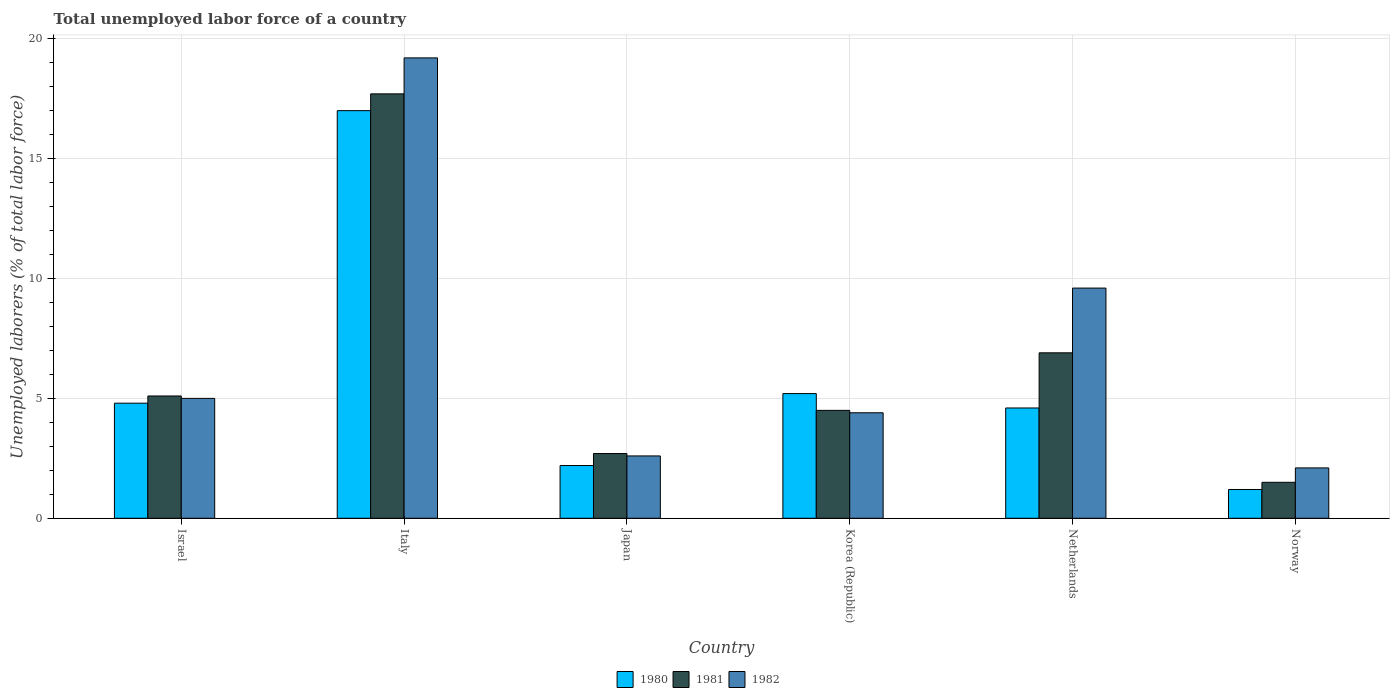How many groups of bars are there?
Offer a very short reply. 6. Are the number of bars per tick equal to the number of legend labels?
Ensure brevity in your answer.  Yes. Are the number of bars on each tick of the X-axis equal?
Your answer should be compact. Yes. How many bars are there on the 1st tick from the right?
Your answer should be very brief. 3. What is the label of the 3rd group of bars from the left?
Offer a terse response. Japan. In how many cases, is the number of bars for a given country not equal to the number of legend labels?
Give a very brief answer. 0. Across all countries, what is the maximum total unemployed labor force in 1982?
Provide a short and direct response. 19.2. Across all countries, what is the minimum total unemployed labor force in 1980?
Give a very brief answer. 1.2. In which country was the total unemployed labor force in 1982 maximum?
Keep it short and to the point. Italy. What is the total total unemployed labor force in 1981 in the graph?
Your response must be concise. 38.4. What is the difference between the total unemployed labor force in 1981 in Israel and that in Italy?
Your response must be concise. -12.6. What is the difference between the total unemployed labor force in 1981 in Norway and the total unemployed labor force in 1982 in Korea (Republic)?
Make the answer very short. -2.9. What is the average total unemployed labor force in 1982 per country?
Provide a succinct answer. 7.15. What is the difference between the total unemployed labor force of/in 1980 and total unemployed labor force of/in 1982 in Netherlands?
Ensure brevity in your answer.  -5. What is the ratio of the total unemployed labor force in 1982 in Japan to that in Netherlands?
Ensure brevity in your answer.  0.27. Is the total unemployed labor force in 1981 in Korea (Republic) less than that in Norway?
Keep it short and to the point. No. Is the difference between the total unemployed labor force in 1980 in Israel and Japan greater than the difference between the total unemployed labor force in 1982 in Israel and Japan?
Ensure brevity in your answer.  Yes. What is the difference between the highest and the second highest total unemployed labor force in 1982?
Offer a terse response. -9.6. What is the difference between the highest and the lowest total unemployed labor force in 1982?
Keep it short and to the point. 17.1. In how many countries, is the total unemployed labor force in 1981 greater than the average total unemployed labor force in 1981 taken over all countries?
Keep it short and to the point. 2. How many bars are there?
Provide a succinct answer. 18. Are all the bars in the graph horizontal?
Ensure brevity in your answer.  No. How many countries are there in the graph?
Your answer should be very brief. 6. Are the values on the major ticks of Y-axis written in scientific E-notation?
Make the answer very short. No. How many legend labels are there?
Provide a short and direct response. 3. What is the title of the graph?
Ensure brevity in your answer.  Total unemployed labor force of a country. Does "2001" appear as one of the legend labels in the graph?
Make the answer very short. No. What is the label or title of the X-axis?
Give a very brief answer. Country. What is the label or title of the Y-axis?
Keep it short and to the point. Unemployed laborers (% of total labor force). What is the Unemployed laborers (% of total labor force) of 1980 in Israel?
Provide a succinct answer. 4.8. What is the Unemployed laborers (% of total labor force) of 1981 in Israel?
Provide a succinct answer. 5.1. What is the Unemployed laborers (% of total labor force) of 1980 in Italy?
Your answer should be very brief. 17. What is the Unemployed laborers (% of total labor force) of 1981 in Italy?
Provide a short and direct response. 17.7. What is the Unemployed laborers (% of total labor force) of 1982 in Italy?
Your answer should be very brief. 19.2. What is the Unemployed laborers (% of total labor force) of 1980 in Japan?
Your answer should be compact. 2.2. What is the Unemployed laborers (% of total labor force) of 1981 in Japan?
Keep it short and to the point. 2.7. What is the Unemployed laborers (% of total labor force) in 1982 in Japan?
Your answer should be compact. 2.6. What is the Unemployed laborers (% of total labor force) of 1980 in Korea (Republic)?
Ensure brevity in your answer.  5.2. What is the Unemployed laborers (% of total labor force) in 1981 in Korea (Republic)?
Give a very brief answer. 4.5. What is the Unemployed laborers (% of total labor force) in 1982 in Korea (Republic)?
Give a very brief answer. 4.4. What is the Unemployed laborers (% of total labor force) of 1980 in Netherlands?
Your answer should be very brief. 4.6. What is the Unemployed laborers (% of total labor force) in 1981 in Netherlands?
Provide a succinct answer. 6.9. What is the Unemployed laborers (% of total labor force) in 1982 in Netherlands?
Your answer should be compact. 9.6. What is the Unemployed laborers (% of total labor force) in 1980 in Norway?
Make the answer very short. 1.2. What is the Unemployed laborers (% of total labor force) of 1981 in Norway?
Keep it short and to the point. 1.5. What is the Unemployed laborers (% of total labor force) in 1982 in Norway?
Offer a terse response. 2.1. Across all countries, what is the maximum Unemployed laborers (% of total labor force) in 1981?
Ensure brevity in your answer.  17.7. Across all countries, what is the maximum Unemployed laborers (% of total labor force) of 1982?
Make the answer very short. 19.2. Across all countries, what is the minimum Unemployed laborers (% of total labor force) of 1980?
Your answer should be very brief. 1.2. Across all countries, what is the minimum Unemployed laborers (% of total labor force) of 1982?
Give a very brief answer. 2.1. What is the total Unemployed laborers (% of total labor force) of 1980 in the graph?
Your answer should be very brief. 35. What is the total Unemployed laborers (% of total labor force) in 1981 in the graph?
Give a very brief answer. 38.4. What is the total Unemployed laborers (% of total labor force) in 1982 in the graph?
Keep it short and to the point. 42.9. What is the difference between the Unemployed laborers (% of total labor force) in 1981 in Israel and that in Italy?
Provide a succinct answer. -12.6. What is the difference between the Unemployed laborers (% of total labor force) in 1982 in Israel and that in Italy?
Keep it short and to the point. -14.2. What is the difference between the Unemployed laborers (% of total labor force) in 1981 in Israel and that in Japan?
Make the answer very short. 2.4. What is the difference between the Unemployed laborers (% of total labor force) in 1980 in Israel and that in Korea (Republic)?
Your answer should be compact. -0.4. What is the difference between the Unemployed laborers (% of total labor force) in 1980 in Italy and that in Japan?
Your answer should be very brief. 14.8. What is the difference between the Unemployed laborers (% of total labor force) of 1981 in Italy and that in Japan?
Provide a short and direct response. 15. What is the difference between the Unemployed laborers (% of total labor force) of 1980 in Italy and that in Korea (Republic)?
Make the answer very short. 11.8. What is the difference between the Unemployed laborers (% of total labor force) of 1981 in Italy and that in Korea (Republic)?
Keep it short and to the point. 13.2. What is the difference between the Unemployed laborers (% of total labor force) of 1982 in Italy and that in Korea (Republic)?
Keep it short and to the point. 14.8. What is the difference between the Unemployed laborers (% of total labor force) of 1980 in Italy and that in Netherlands?
Give a very brief answer. 12.4. What is the difference between the Unemployed laborers (% of total labor force) in 1982 in Italy and that in Netherlands?
Provide a short and direct response. 9.6. What is the difference between the Unemployed laborers (% of total labor force) in 1980 in Italy and that in Norway?
Your answer should be very brief. 15.8. What is the difference between the Unemployed laborers (% of total labor force) of 1981 in Italy and that in Norway?
Give a very brief answer. 16.2. What is the difference between the Unemployed laborers (% of total labor force) of 1982 in Italy and that in Norway?
Give a very brief answer. 17.1. What is the difference between the Unemployed laborers (% of total labor force) in 1982 in Japan and that in Korea (Republic)?
Provide a short and direct response. -1.8. What is the difference between the Unemployed laborers (% of total labor force) in 1982 in Japan and that in Netherlands?
Make the answer very short. -7. What is the difference between the Unemployed laborers (% of total labor force) of 1982 in Japan and that in Norway?
Ensure brevity in your answer.  0.5. What is the difference between the Unemployed laborers (% of total labor force) in 1982 in Korea (Republic) and that in Netherlands?
Provide a succinct answer. -5.2. What is the difference between the Unemployed laborers (% of total labor force) in 1980 in Korea (Republic) and that in Norway?
Your answer should be compact. 4. What is the difference between the Unemployed laborers (% of total labor force) in 1981 in Korea (Republic) and that in Norway?
Ensure brevity in your answer.  3. What is the difference between the Unemployed laborers (% of total labor force) in 1982 in Korea (Republic) and that in Norway?
Keep it short and to the point. 2.3. What is the difference between the Unemployed laborers (% of total labor force) of 1981 in Netherlands and that in Norway?
Give a very brief answer. 5.4. What is the difference between the Unemployed laborers (% of total labor force) in 1982 in Netherlands and that in Norway?
Offer a terse response. 7.5. What is the difference between the Unemployed laborers (% of total labor force) in 1980 in Israel and the Unemployed laborers (% of total labor force) in 1982 in Italy?
Keep it short and to the point. -14.4. What is the difference between the Unemployed laborers (% of total labor force) in 1981 in Israel and the Unemployed laborers (% of total labor force) in 1982 in Italy?
Offer a terse response. -14.1. What is the difference between the Unemployed laborers (% of total labor force) in 1980 in Israel and the Unemployed laborers (% of total labor force) in 1982 in Japan?
Offer a terse response. 2.2. What is the difference between the Unemployed laborers (% of total labor force) of 1981 in Israel and the Unemployed laborers (% of total labor force) of 1982 in Japan?
Offer a terse response. 2.5. What is the difference between the Unemployed laborers (% of total labor force) in 1980 in Israel and the Unemployed laborers (% of total labor force) in 1982 in Korea (Republic)?
Give a very brief answer. 0.4. What is the difference between the Unemployed laborers (% of total labor force) of 1981 in Israel and the Unemployed laborers (% of total labor force) of 1982 in Korea (Republic)?
Provide a succinct answer. 0.7. What is the difference between the Unemployed laborers (% of total labor force) of 1980 in Israel and the Unemployed laborers (% of total labor force) of 1982 in Netherlands?
Ensure brevity in your answer.  -4.8. What is the difference between the Unemployed laborers (% of total labor force) in 1981 in Israel and the Unemployed laborers (% of total labor force) in 1982 in Netherlands?
Your answer should be compact. -4.5. What is the difference between the Unemployed laborers (% of total labor force) in 1981 in Israel and the Unemployed laborers (% of total labor force) in 1982 in Norway?
Give a very brief answer. 3. What is the difference between the Unemployed laborers (% of total labor force) of 1980 in Italy and the Unemployed laborers (% of total labor force) of 1982 in Japan?
Provide a succinct answer. 14.4. What is the difference between the Unemployed laborers (% of total labor force) in 1980 in Italy and the Unemployed laborers (% of total labor force) in 1981 in Korea (Republic)?
Provide a short and direct response. 12.5. What is the difference between the Unemployed laborers (% of total labor force) in 1980 in Italy and the Unemployed laborers (% of total labor force) in 1981 in Netherlands?
Offer a terse response. 10.1. What is the difference between the Unemployed laborers (% of total labor force) of 1980 in Italy and the Unemployed laborers (% of total labor force) of 1981 in Norway?
Your answer should be compact. 15.5. What is the difference between the Unemployed laborers (% of total labor force) in 1981 in Italy and the Unemployed laborers (% of total labor force) in 1982 in Norway?
Your answer should be compact. 15.6. What is the difference between the Unemployed laborers (% of total labor force) of 1980 in Japan and the Unemployed laborers (% of total labor force) of 1981 in Korea (Republic)?
Offer a terse response. -2.3. What is the difference between the Unemployed laborers (% of total labor force) of 1981 in Japan and the Unemployed laborers (% of total labor force) of 1982 in Korea (Republic)?
Your answer should be very brief. -1.7. What is the difference between the Unemployed laborers (% of total labor force) of 1980 in Japan and the Unemployed laborers (% of total labor force) of 1982 in Netherlands?
Your answer should be very brief. -7.4. What is the difference between the Unemployed laborers (% of total labor force) in 1980 in Japan and the Unemployed laborers (% of total labor force) in 1981 in Norway?
Your answer should be compact. 0.7. What is the difference between the Unemployed laborers (% of total labor force) in 1980 in Japan and the Unemployed laborers (% of total labor force) in 1982 in Norway?
Give a very brief answer. 0.1. What is the difference between the Unemployed laborers (% of total labor force) in 1981 in Japan and the Unemployed laborers (% of total labor force) in 1982 in Norway?
Your response must be concise. 0.6. What is the difference between the Unemployed laborers (% of total labor force) of 1980 in Korea (Republic) and the Unemployed laborers (% of total labor force) of 1982 in Netherlands?
Offer a very short reply. -4.4. What is the difference between the Unemployed laborers (% of total labor force) of 1980 in Korea (Republic) and the Unemployed laborers (% of total labor force) of 1982 in Norway?
Your answer should be compact. 3.1. What is the difference between the Unemployed laborers (% of total labor force) of 1981 in Korea (Republic) and the Unemployed laborers (% of total labor force) of 1982 in Norway?
Your answer should be very brief. 2.4. What is the difference between the Unemployed laborers (% of total labor force) of 1980 in Netherlands and the Unemployed laborers (% of total labor force) of 1982 in Norway?
Give a very brief answer. 2.5. What is the average Unemployed laborers (% of total labor force) in 1980 per country?
Give a very brief answer. 5.83. What is the average Unemployed laborers (% of total labor force) of 1982 per country?
Provide a short and direct response. 7.15. What is the difference between the Unemployed laborers (% of total labor force) in 1980 and Unemployed laborers (% of total labor force) in 1982 in Italy?
Provide a short and direct response. -2.2. What is the difference between the Unemployed laborers (% of total labor force) of 1981 and Unemployed laborers (% of total labor force) of 1982 in Japan?
Make the answer very short. 0.1. What is the difference between the Unemployed laborers (% of total labor force) of 1980 and Unemployed laborers (% of total labor force) of 1981 in Korea (Republic)?
Ensure brevity in your answer.  0.7. What is the difference between the Unemployed laborers (% of total labor force) of 1981 and Unemployed laborers (% of total labor force) of 1982 in Netherlands?
Your answer should be very brief. -2.7. What is the ratio of the Unemployed laborers (% of total labor force) in 1980 in Israel to that in Italy?
Make the answer very short. 0.28. What is the ratio of the Unemployed laborers (% of total labor force) of 1981 in Israel to that in Italy?
Provide a succinct answer. 0.29. What is the ratio of the Unemployed laborers (% of total labor force) of 1982 in Israel to that in Italy?
Ensure brevity in your answer.  0.26. What is the ratio of the Unemployed laborers (% of total labor force) in 1980 in Israel to that in Japan?
Offer a very short reply. 2.18. What is the ratio of the Unemployed laborers (% of total labor force) of 1981 in Israel to that in Japan?
Give a very brief answer. 1.89. What is the ratio of the Unemployed laborers (% of total labor force) in 1982 in Israel to that in Japan?
Your answer should be very brief. 1.92. What is the ratio of the Unemployed laborers (% of total labor force) in 1980 in Israel to that in Korea (Republic)?
Your answer should be compact. 0.92. What is the ratio of the Unemployed laborers (% of total labor force) in 1981 in Israel to that in Korea (Republic)?
Your response must be concise. 1.13. What is the ratio of the Unemployed laborers (% of total labor force) of 1982 in Israel to that in Korea (Republic)?
Offer a very short reply. 1.14. What is the ratio of the Unemployed laborers (% of total labor force) in 1980 in Israel to that in Netherlands?
Offer a very short reply. 1.04. What is the ratio of the Unemployed laborers (% of total labor force) of 1981 in Israel to that in Netherlands?
Your answer should be very brief. 0.74. What is the ratio of the Unemployed laborers (% of total labor force) of 1982 in Israel to that in Netherlands?
Your answer should be very brief. 0.52. What is the ratio of the Unemployed laborers (% of total labor force) in 1980 in Israel to that in Norway?
Your response must be concise. 4. What is the ratio of the Unemployed laborers (% of total labor force) of 1981 in Israel to that in Norway?
Offer a terse response. 3.4. What is the ratio of the Unemployed laborers (% of total labor force) in 1982 in Israel to that in Norway?
Ensure brevity in your answer.  2.38. What is the ratio of the Unemployed laborers (% of total labor force) of 1980 in Italy to that in Japan?
Make the answer very short. 7.73. What is the ratio of the Unemployed laborers (% of total labor force) of 1981 in Italy to that in Japan?
Your answer should be compact. 6.56. What is the ratio of the Unemployed laborers (% of total labor force) of 1982 in Italy to that in Japan?
Make the answer very short. 7.38. What is the ratio of the Unemployed laborers (% of total labor force) in 1980 in Italy to that in Korea (Republic)?
Provide a short and direct response. 3.27. What is the ratio of the Unemployed laborers (% of total labor force) of 1981 in Italy to that in Korea (Republic)?
Your response must be concise. 3.93. What is the ratio of the Unemployed laborers (% of total labor force) of 1982 in Italy to that in Korea (Republic)?
Your response must be concise. 4.36. What is the ratio of the Unemployed laborers (% of total labor force) in 1980 in Italy to that in Netherlands?
Your answer should be very brief. 3.7. What is the ratio of the Unemployed laborers (% of total labor force) of 1981 in Italy to that in Netherlands?
Keep it short and to the point. 2.57. What is the ratio of the Unemployed laborers (% of total labor force) of 1980 in Italy to that in Norway?
Offer a terse response. 14.17. What is the ratio of the Unemployed laborers (% of total labor force) in 1982 in Italy to that in Norway?
Offer a terse response. 9.14. What is the ratio of the Unemployed laborers (% of total labor force) in 1980 in Japan to that in Korea (Republic)?
Ensure brevity in your answer.  0.42. What is the ratio of the Unemployed laborers (% of total labor force) of 1981 in Japan to that in Korea (Republic)?
Provide a short and direct response. 0.6. What is the ratio of the Unemployed laborers (% of total labor force) of 1982 in Japan to that in Korea (Republic)?
Ensure brevity in your answer.  0.59. What is the ratio of the Unemployed laborers (% of total labor force) in 1980 in Japan to that in Netherlands?
Provide a short and direct response. 0.48. What is the ratio of the Unemployed laborers (% of total labor force) of 1981 in Japan to that in Netherlands?
Offer a very short reply. 0.39. What is the ratio of the Unemployed laborers (% of total labor force) in 1982 in Japan to that in Netherlands?
Offer a terse response. 0.27. What is the ratio of the Unemployed laborers (% of total labor force) of 1980 in Japan to that in Norway?
Offer a very short reply. 1.83. What is the ratio of the Unemployed laborers (% of total labor force) of 1982 in Japan to that in Norway?
Your answer should be compact. 1.24. What is the ratio of the Unemployed laborers (% of total labor force) in 1980 in Korea (Republic) to that in Netherlands?
Your answer should be compact. 1.13. What is the ratio of the Unemployed laborers (% of total labor force) in 1981 in Korea (Republic) to that in Netherlands?
Offer a terse response. 0.65. What is the ratio of the Unemployed laborers (% of total labor force) of 1982 in Korea (Republic) to that in Netherlands?
Your answer should be compact. 0.46. What is the ratio of the Unemployed laborers (% of total labor force) in 1980 in Korea (Republic) to that in Norway?
Offer a terse response. 4.33. What is the ratio of the Unemployed laborers (% of total labor force) in 1982 in Korea (Republic) to that in Norway?
Keep it short and to the point. 2.1. What is the ratio of the Unemployed laborers (% of total labor force) in 1980 in Netherlands to that in Norway?
Your answer should be very brief. 3.83. What is the ratio of the Unemployed laborers (% of total labor force) in 1982 in Netherlands to that in Norway?
Your answer should be very brief. 4.57. What is the difference between the highest and the second highest Unemployed laborers (% of total labor force) in 1980?
Offer a very short reply. 11.8. What is the difference between the highest and the second highest Unemployed laborers (% of total labor force) of 1982?
Your answer should be very brief. 9.6. What is the difference between the highest and the lowest Unemployed laborers (% of total labor force) of 1981?
Give a very brief answer. 16.2. What is the difference between the highest and the lowest Unemployed laborers (% of total labor force) of 1982?
Offer a terse response. 17.1. 